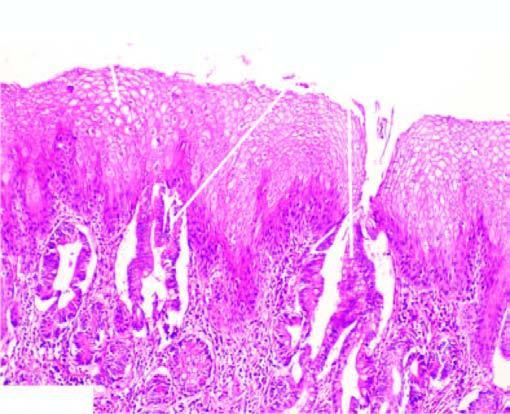what undergoes metaplastic change to columnar epithelium of intestinal type?
Answer the question using a single word or phrase. Part of the oesophagus 